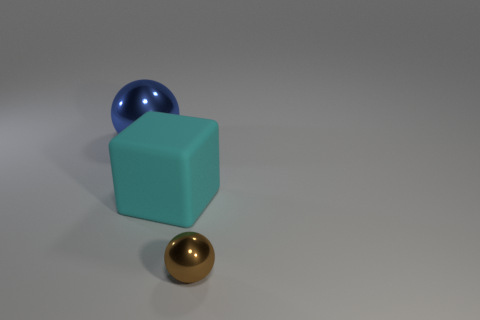Is the shape of the big blue object on the left side of the cyan rubber thing the same as  the large cyan matte thing?
Offer a very short reply. No. Are there more small metal balls behind the large cyan cube than large red metal blocks?
Ensure brevity in your answer.  No. There is a metal sphere left of the big thing in front of the blue metal ball; what is its color?
Offer a very short reply. Blue. What number of big gray rubber cylinders are there?
Your answer should be compact. 0. How many objects are behind the cyan matte cube and on the right side of the cyan object?
Give a very brief answer. 0. Is there any other thing that is the same shape as the large shiny object?
Ensure brevity in your answer.  Yes. Is the color of the small thing the same as the sphere that is behind the small thing?
Offer a terse response. No. What is the shape of the metal object that is to the right of the big blue sphere?
Offer a very short reply. Sphere. What number of other things are made of the same material as the cyan cube?
Give a very brief answer. 0. What material is the cube?
Make the answer very short. Rubber. 